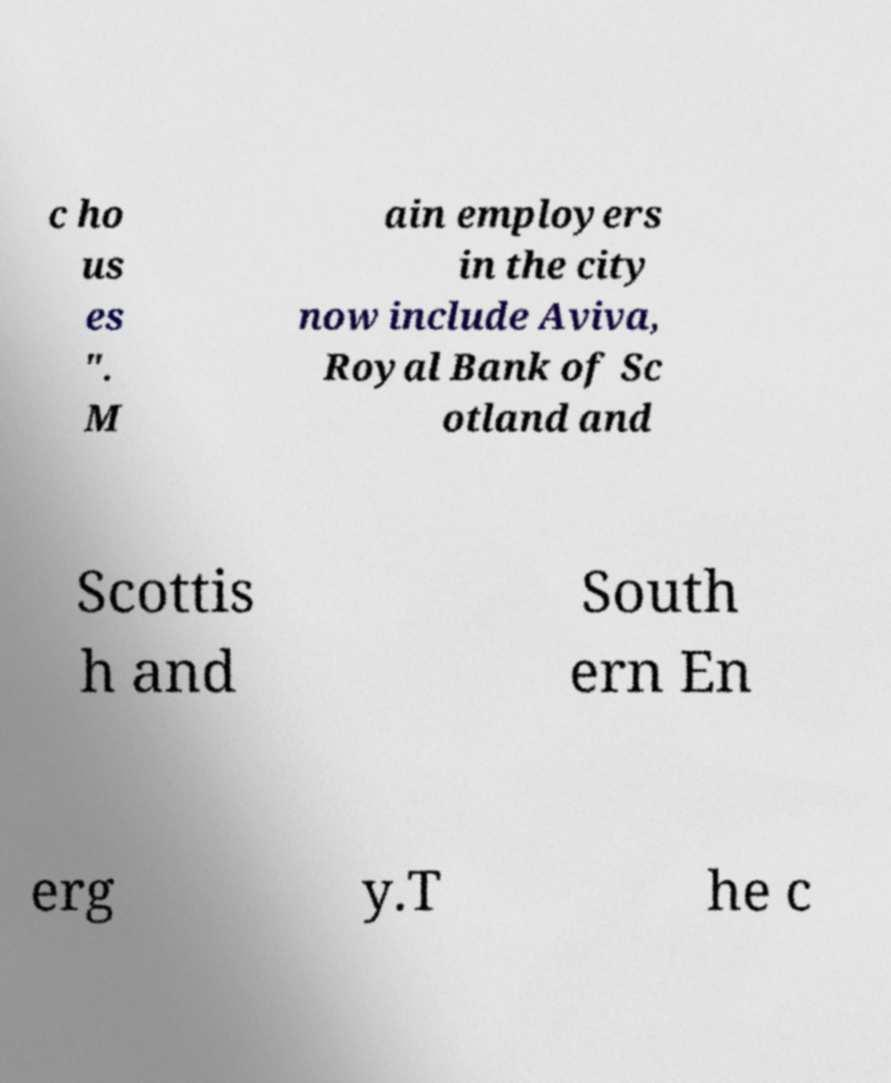Can you accurately transcribe the text from the provided image for me? c ho us es ". M ain employers in the city now include Aviva, Royal Bank of Sc otland and Scottis h and South ern En erg y.T he c 